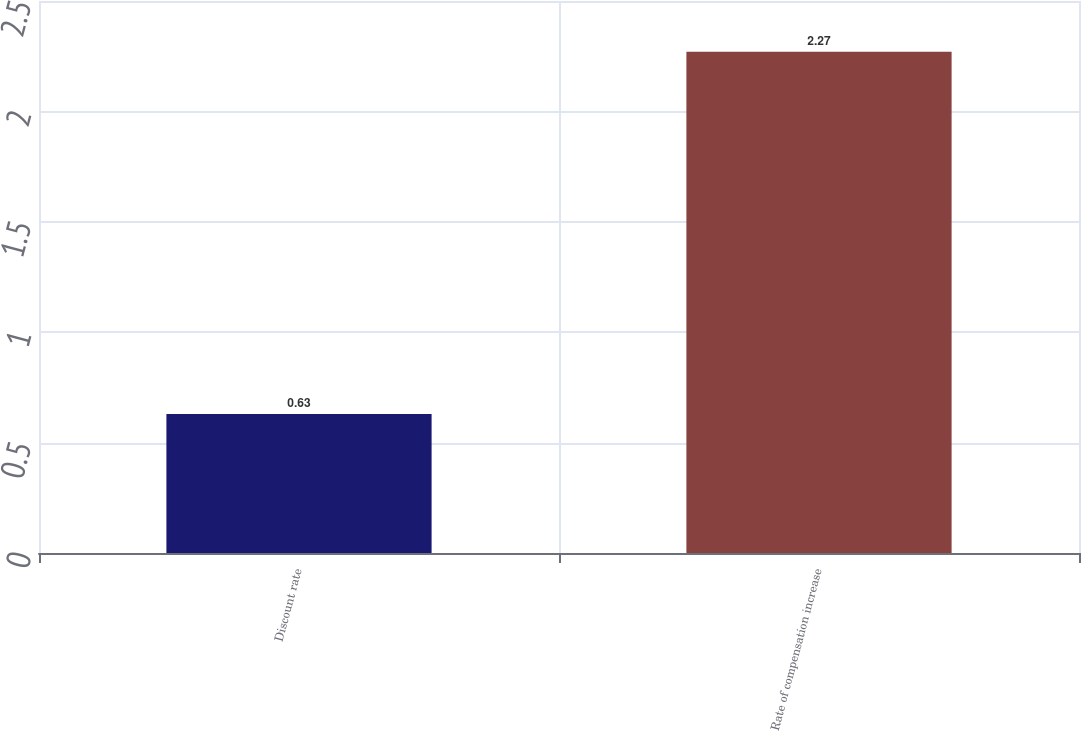Convert chart. <chart><loc_0><loc_0><loc_500><loc_500><bar_chart><fcel>Discount rate<fcel>Rate of compensation increase<nl><fcel>0.63<fcel>2.27<nl></chart> 